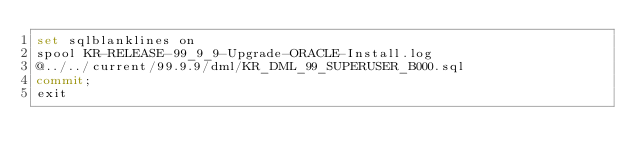Convert code to text. <code><loc_0><loc_0><loc_500><loc_500><_SQL_>set sqlblanklines on
spool KR-RELEASE-99_9_9-Upgrade-ORACLE-Install.log
@../../current/99.9.9/dml/KR_DML_99_SUPERUSER_B000.sql
commit;
exit
</code> 